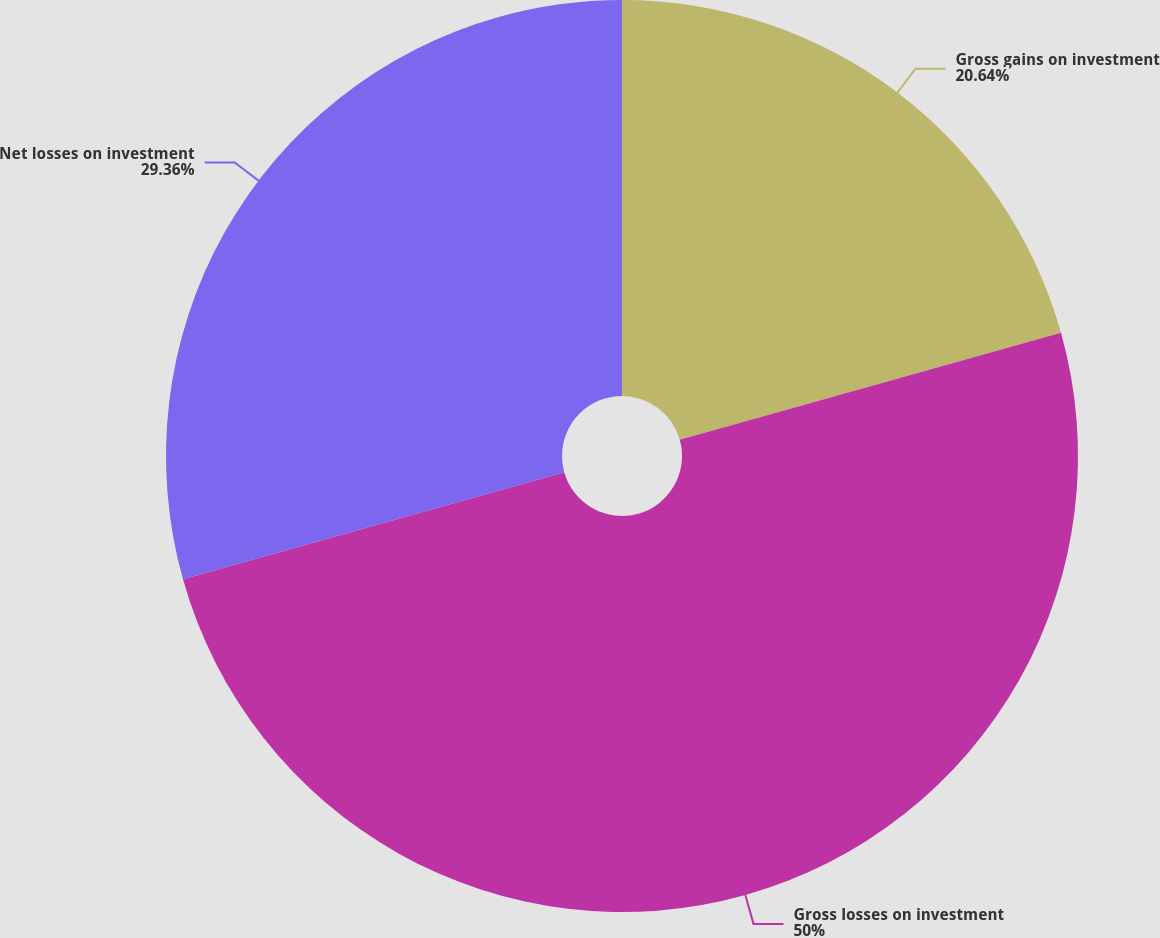<chart> <loc_0><loc_0><loc_500><loc_500><pie_chart><fcel>Gross gains on investment<fcel>Gross losses on investment<fcel>Net losses on investment<nl><fcel>20.64%<fcel>50.0%<fcel>29.36%<nl></chart> 